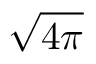<formula> <loc_0><loc_0><loc_500><loc_500>\sqrt { 4 \pi }</formula> 